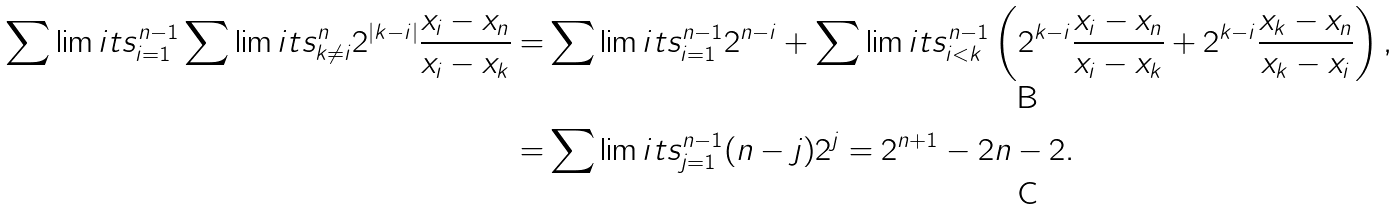<formula> <loc_0><loc_0><loc_500><loc_500>\sum \lim i t s _ { i = 1 } ^ { n - 1 } \sum \lim i t s _ { k \neq i } ^ { n } 2 ^ { | k - i | } \frac { x _ { i } - x _ { n } } { x _ { i } - x _ { k } } = & \sum \lim i t s _ { i = 1 } ^ { n - 1 } 2 ^ { n - i } + \sum \lim i t s _ { i < k } ^ { n - 1 } \left ( 2 ^ { k - i } \frac { x _ { i } - x _ { n } } { x _ { i } - x _ { k } } + 2 ^ { k - i } \frac { x _ { k } - x _ { n } } { x _ { k } - x _ { i } } \right ) , \\ = & \sum \lim i t s _ { j = 1 } ^ { n - 1 } ( n - j ) 2 ^ { j } = 2 ^ { n + 1 } - 2 n - 2 .</formula> 